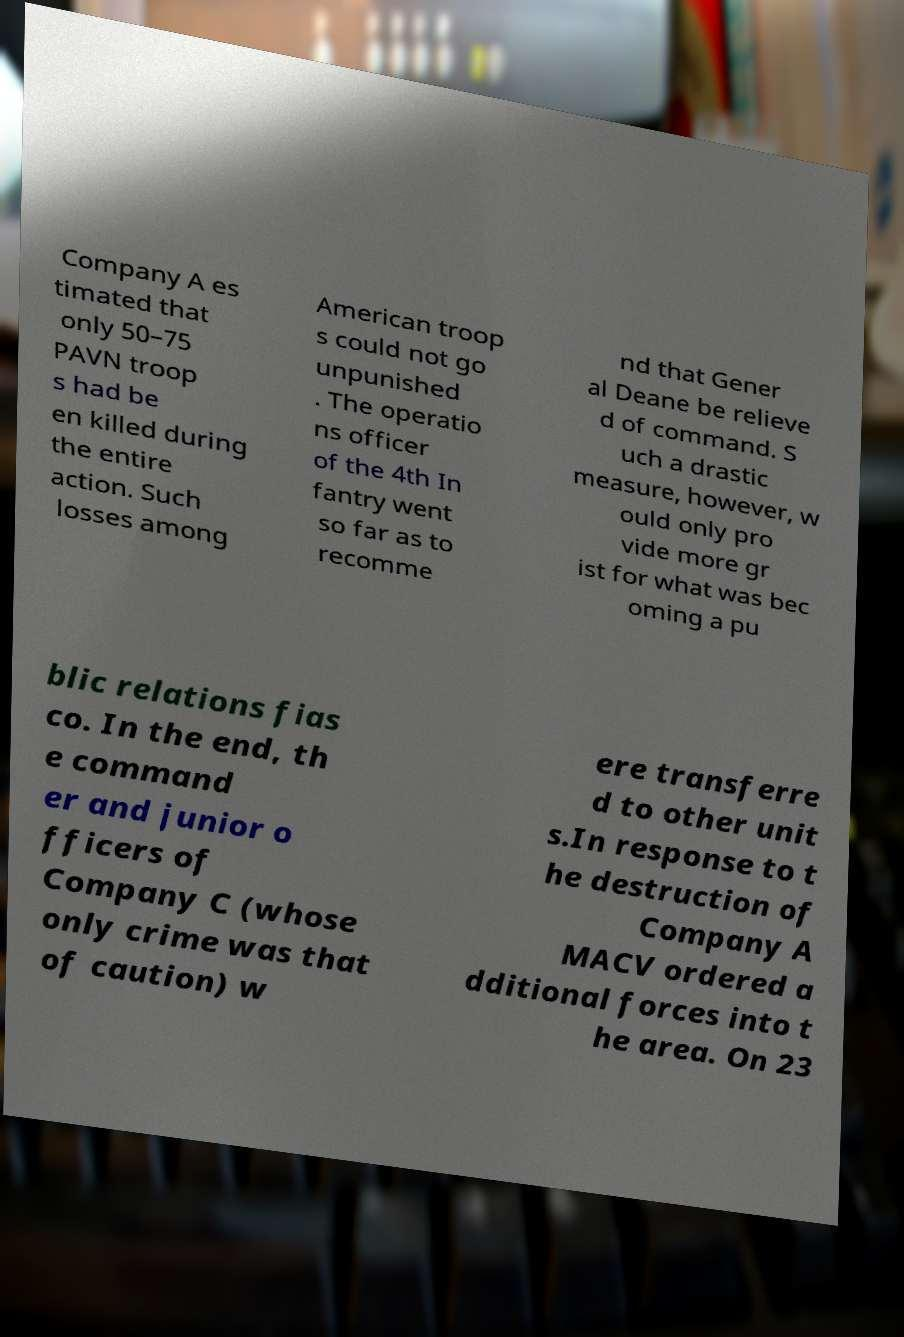What messages or text are displayed in this image? I need them in a readable, typed format. Company A es timated that only 50–75 PAVN troop s had be en killed during the entire action. Such losses among American troop s could not go unpunished . The operatio ns officer of the 4th In fantry went so far as to recomme nd that Gener al Deane be relieve d of command. S uch a drastic measure, however, w ould only pro vide more gr ist for what was bec oming a pu blic relations fias co. In the end, th e command er and junior o fficers of Company C (whose only crime was that of caution) w ere transferre d to other unit s.In response to t he destruction of Company A MACV ordered a dditional forces into t he area. On 23 